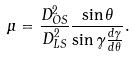<formula> <loc_0><loc_0><loc_500><loc_500>\mu = \frac { D _ { O S } ^ { 2 } } { D _ { L S } ^ { 2 } } \frac { \sin \theta } { \sin { \gamma } \frac { d \gamma } { d \theta } } .</formula> 